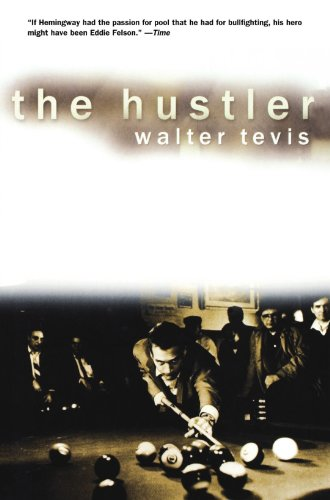What is the title of this book? The title of the book is 'The Hustler', which is a renowned novel focused on the life and times of a skilled pool player. 